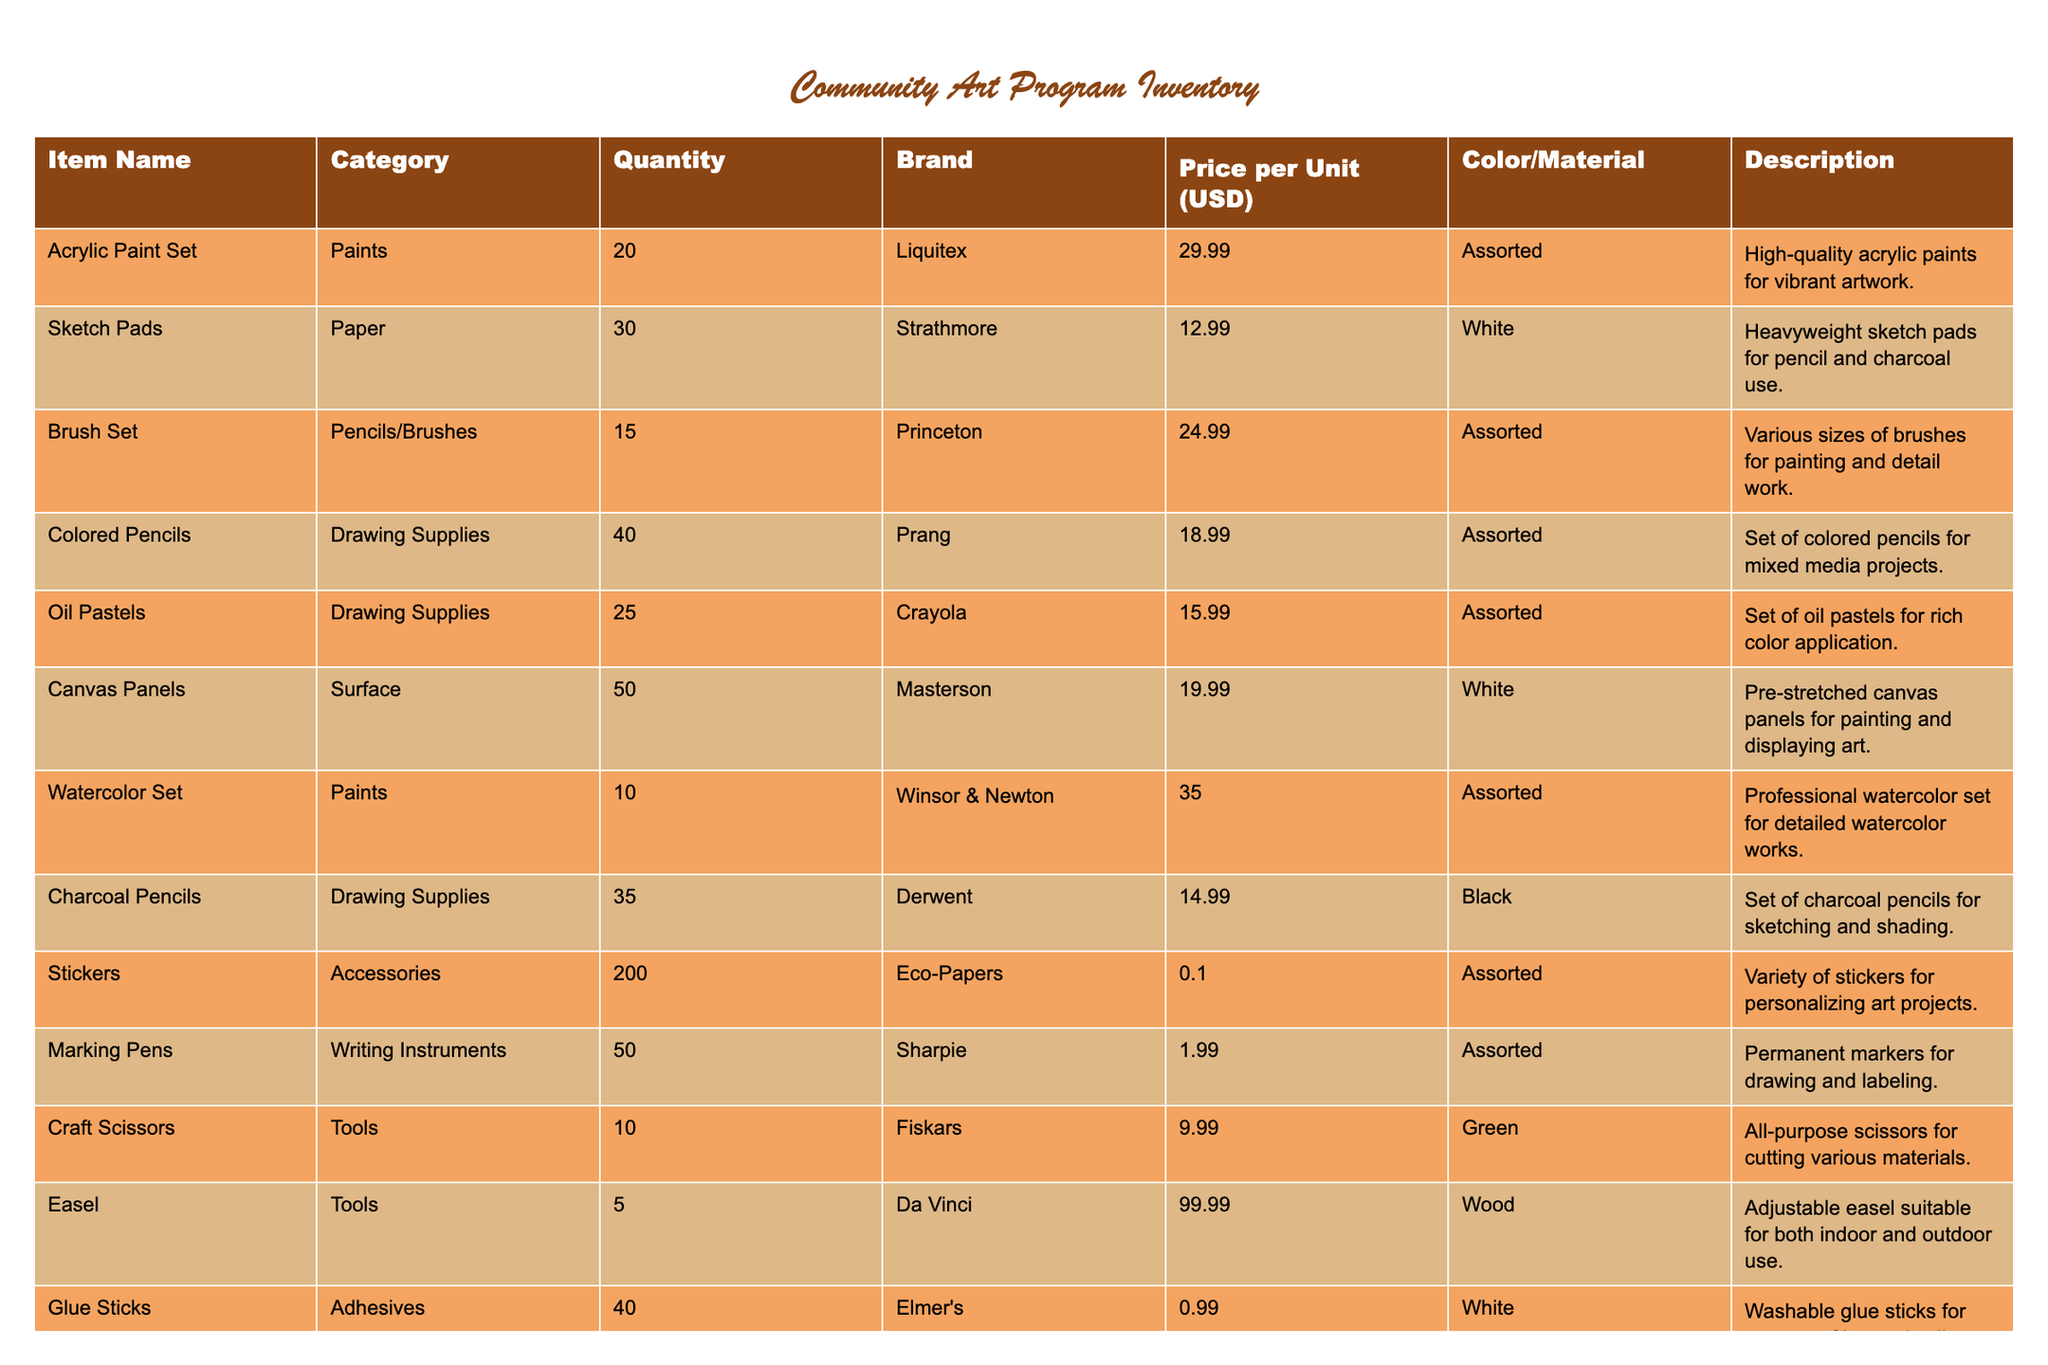What is the total quantity of Acrylic Paint Set available? From the table, the Acrylic Paint Set's Quantity column shows that there are 20 units of it available.
Answer: 20 How many different categories of art supplies are listed in the inventory? The table lists various categories in the Category column. By counting unique entries, we see categories like Paints, Paper, Pencils/Brushes, Drawing Supplies, Surface, Accessories, Tools, and Adhesives exist, totaling 8 distinct categories.
Answer: 8 What is the item with the highest price per unit? By examining the Price per Unit column, the highest value is 99.99 from the Easel (Da Vinci brand).
Answer: Easel Are there more Colored Pencils or Charcoal Pencils in inventory? The Quantity for Colored Pencils is 40, whereas Charcoal Pencils have 35. Since 40 is greater than 35, there are more Colored Pencils in stock.
Answer: Yes, more Colored Pencils What is the total cost of purchasing all available Canvas Panels? The Quantity of Canvas Panels is 50, and the Price per Unit is 19.99. To find the total cost, multiply 50 by 19.99, which equals 999.50.
Answer: 999.50 What fraction of the total quantity is represented by Stickers in the inventory? First, total all quantities: 20 + 30 + 15 + 40 + 25 + 50 + 10 + 35 + 200 + 50 + 10 + 5 + 40 + 100 + 20 = 445. The quantity of Stickers is 200; therefore, the fraction is 200/445, which simplifies approximately to 0.449.
Answer: 0.449 Which brand has the largest number of items available in inventory? To determine this, we need to compare the total quantities grouped by brand. The brand Eco-Papers (Stickers) has 200, while others have less, confirming that Eco-Papers has the highest total count of inventory.
Answer: Eco-Papers Is there more inventory quantity overall for Drawing Supplies compared to Tools? The total quantity for Drawing Supplies (Colored Pencils + Oil Pastels + Charcoal Pencils = 40 + 25 + 35 = 100) against Tools (Craft Scissors + Easel = 10 + 5 = 15). Since 100 is more than 15, the answer is yes.
Answer: Yes, more Drawing Supplies What is the average price per unit of all items in the inventory? The total prices for each item are calculated and summed up. The total price (sum of all Price per Unit multiplied by Quantity) is 1,135.85, divided by the total quantity (445) gives us an average price of approximately 2.55 when rounded.
Answer: 2.55 